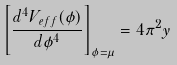<formula> <loc_0><loc_0><loc_500><loc_500>\left [ \frac { d ^ { 4 } V _ { e f f } ( \phi ) } { d \phi ^ { 4 } } \right ] _ { \phi = \mu } = 4 \pi ^ { 2 } y</formula> 